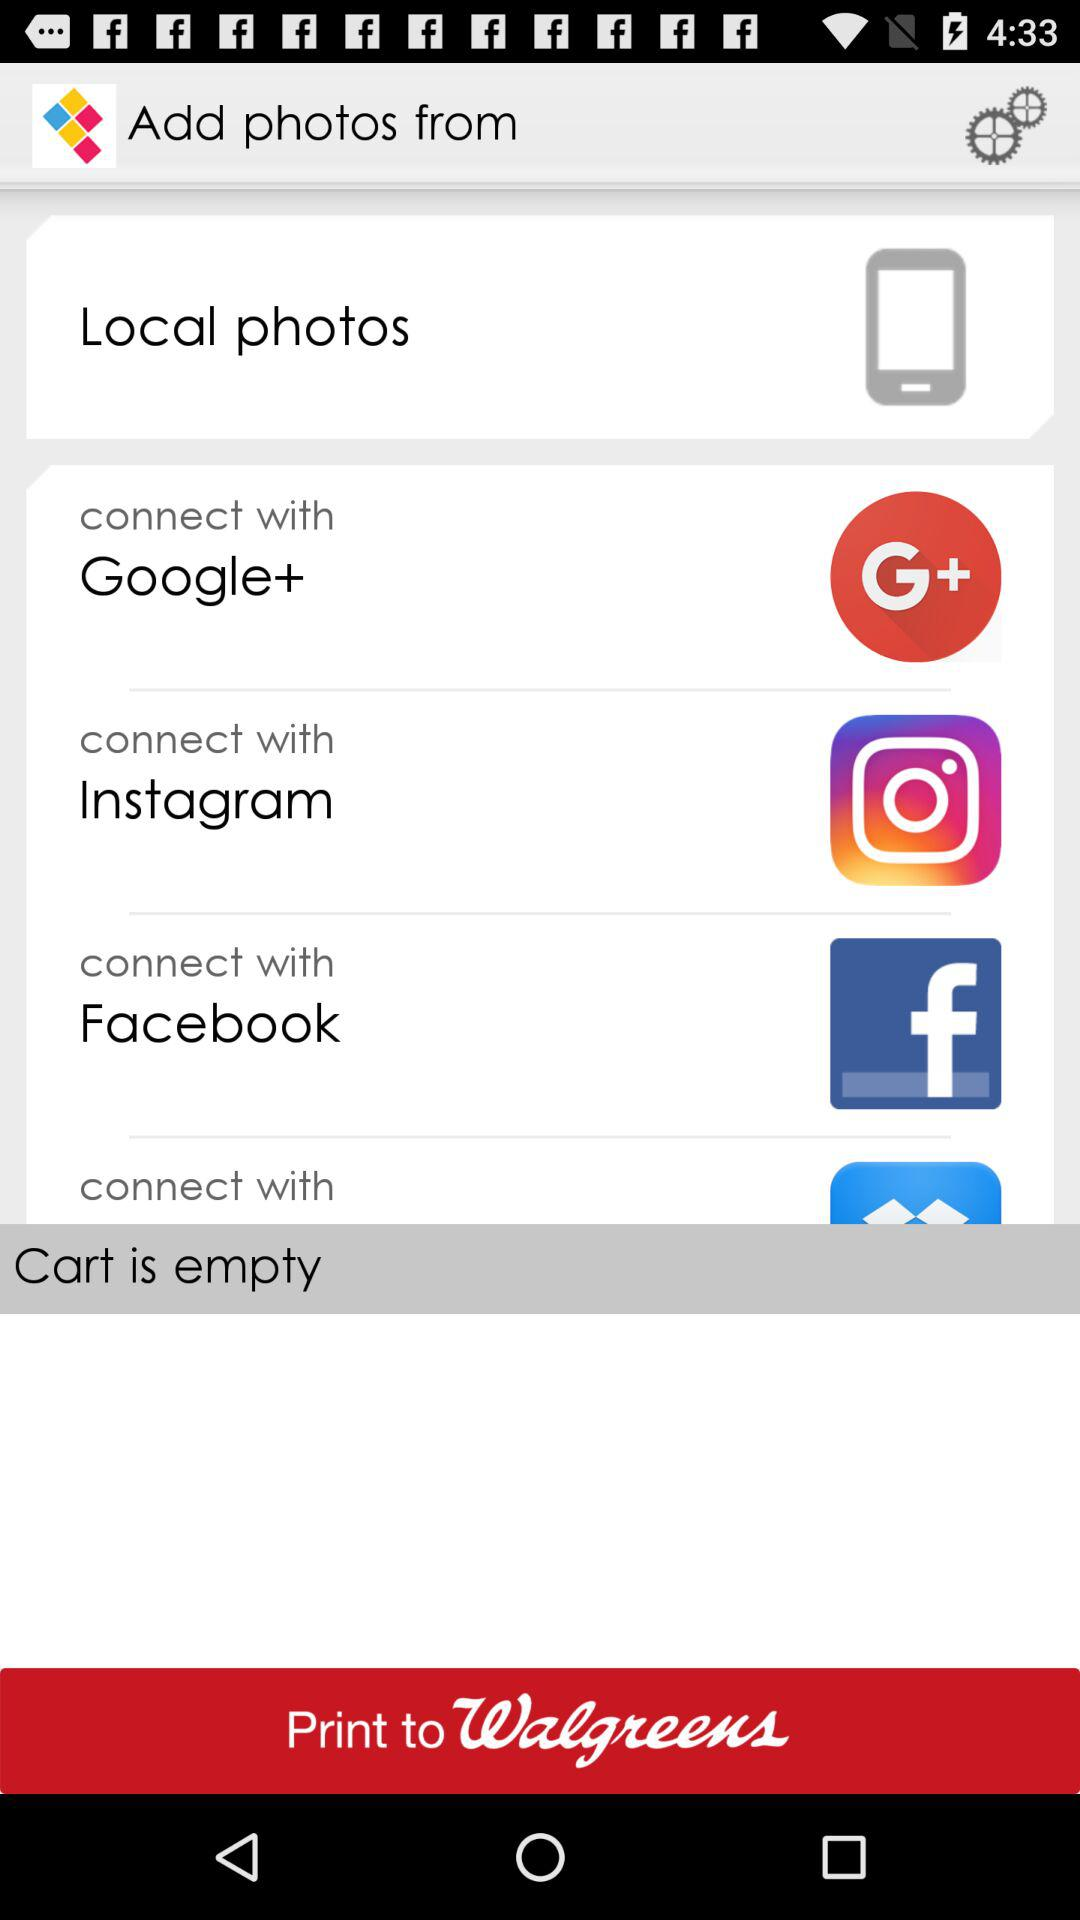How many options are there to connect with?
Answer the question using a single word or phrase. 4 